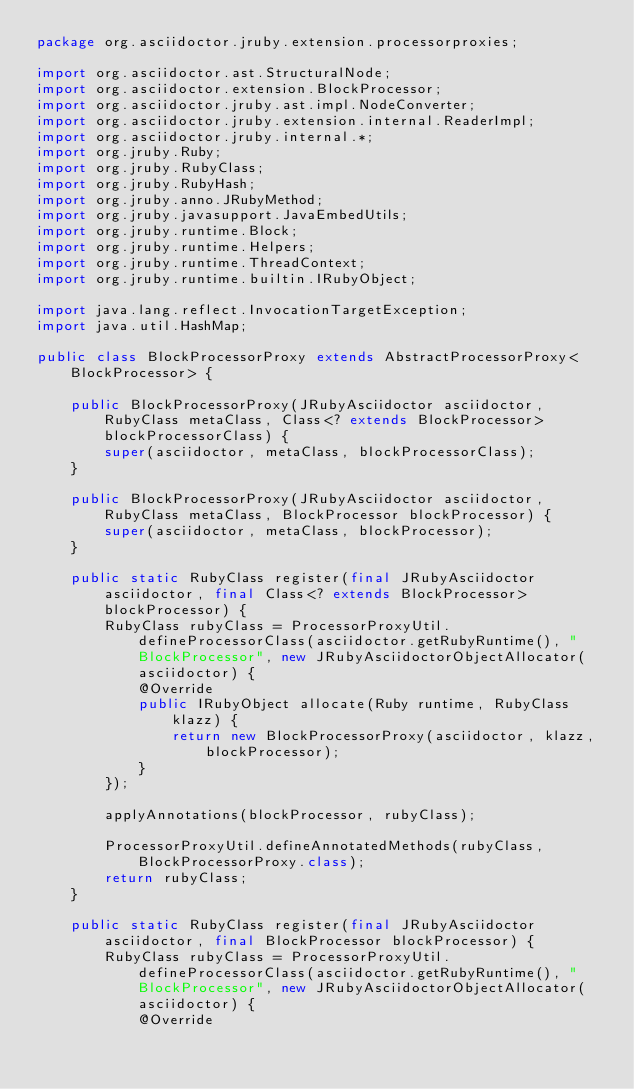<code> <loc_0><loc_0><loc_500><loc_500><_Java_>package org.asciidoctor.jruby.extension.processorproxies;

import org.asciidoctor.ast.StructuralNode;
import org.asciidoctor.extension.BlockProcessor;
import org.asciidoctor.jruby.ast.impl.NodeConverter;
import org.asciidoctor.jruby.extension.internal.ReaderImpl;
import org.asciidoctor.jruby.internal.*;
import org.jruby.Ruby;
import org.jruby.RubyClass;
import org.jruby.RubyHash;
import org.jruby.anno.JRubyMethod;
import org.jruby.javasupport.JavaEmbedUtils;
import org.jruby.runtime.Block;
import org.jruby.runtime.Helpers;
import org.jruby.runtime.ThreadContext;
import org.jruby.runtime.builtin.IRubyObject;

import java.lang.reflect.InvocationTargetException;
import java.util.HashMap;

public class BlockProcessorProxy extends AbstractProcessorProxy<BlockProcessor> {

    public BlockProcessorProxy(JRubyAsciidoctor asciidoctor, RubyClass metaClass, Class<? extends BlockProcessor> blockProcessorClass) {
        super(asciidoctor, metaClass, blockProcessorClass);
    }

    public BlockProcessorProxy(JRubyAsciidoctor asciidoctor, RubyClass metaClass, BlockProcessor blockProcessor) {
        super(asciidoctor, metaClass, blockProcessor);
    }

    public static RubyClass register(final JRubyAsciidoctor asciidoctor, final Class<? extends BlockProcessor> blockProcessor) {
        RubyClass rubyClass = ProcessorProxyUtil.defineProcessorClass(asciidoctor.getRubyRuntime(), "BlockProcessor", new JRubyAsciidoctorObjectAllocator(asciidoctor) {
            @Override
            public IRubyObject allocate(Ruby runtime, RubyClass klazz) {
                return new BlockProcessorProxy(asciidoctor, klazz, blockProcessor);
            }
        });

        applyAnnotations(blockProcessor, rubyClass);

        ProcessorProxyUtil.defineAnnotatedMethods(rubyClass, BlockProcessorProxy.class);
        return rubyClass;
    }

    public static RubyClass register(final JRubyAsciidoctor asciidoctor, final BlockProcessor blockProcessor) {
        RubyClass rubyClass = ProcessorProxyUtil.defineProcessorClass(asciidoctor.getRubyRuntime(), "BlockProcessor", new JRubyAsciidoctorObjectAllocator(asciidoctor) {
            @Override</code> 